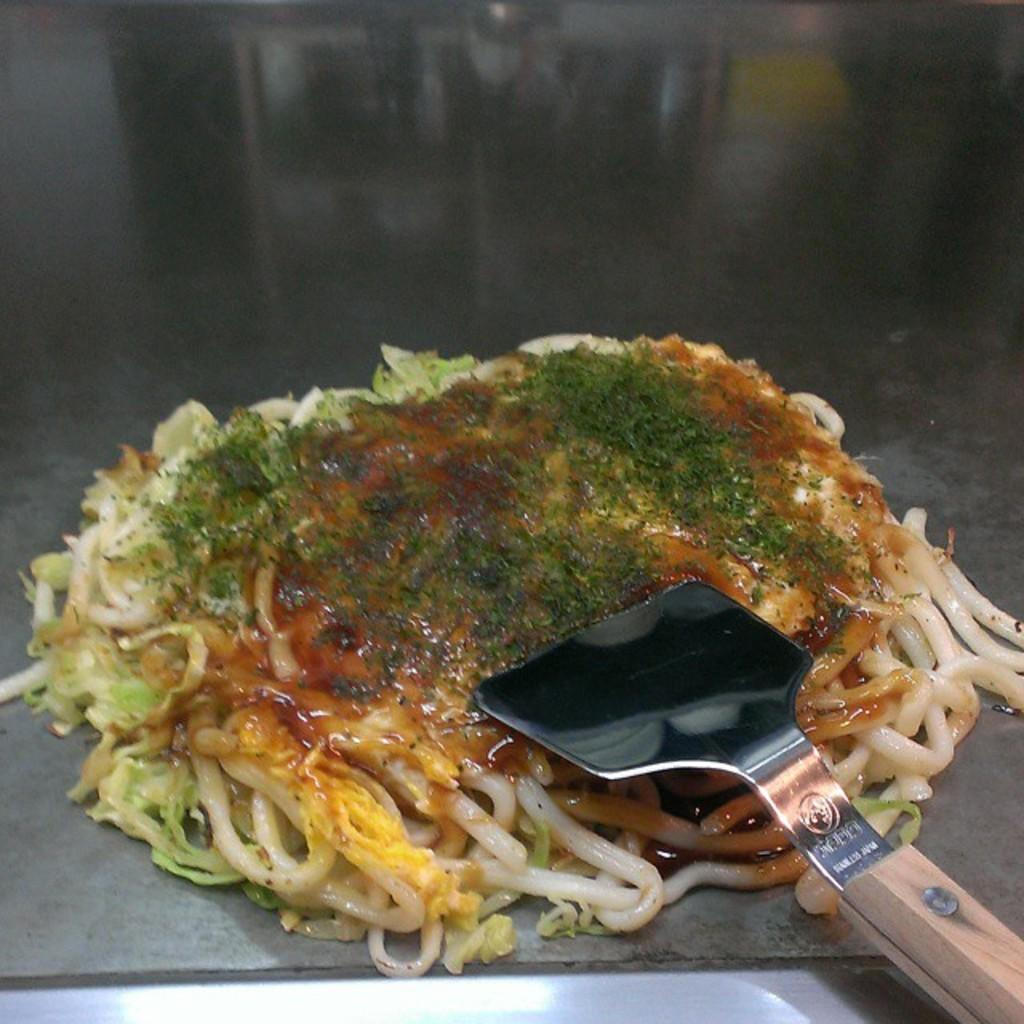What is the main subject of the image? There is a food item in the image. What is the food item placed on? The food item is on a metal object. What utensil can be seen in the image? There is a spatula in the image. How many clocks are visible in the image? There are no clocks visible in the image. What type of work is being done in the image? There is no indication of work being done in the image. 